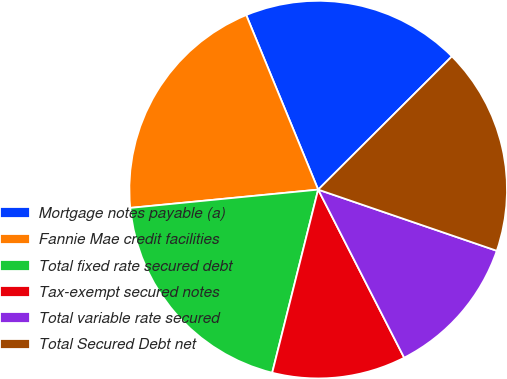Convert chart. <chart><loc_0><loc_0><loc_500><loc_500><pie_chart><fcel>Mortgage notes payable (a)<fcel>Fannie Mae credit facilities<fcel>Total fixed rate secured debt<fcel>Tax-exempt secured notes<fcel>Total variable rate secured<fcel>Total Secured Debt net<nl><fcel>18.75%<fcel>20.32%<fcel>19.54%<fcel>11.44%<fcel>12.22%<fcel>17.72%<nl></chart> 